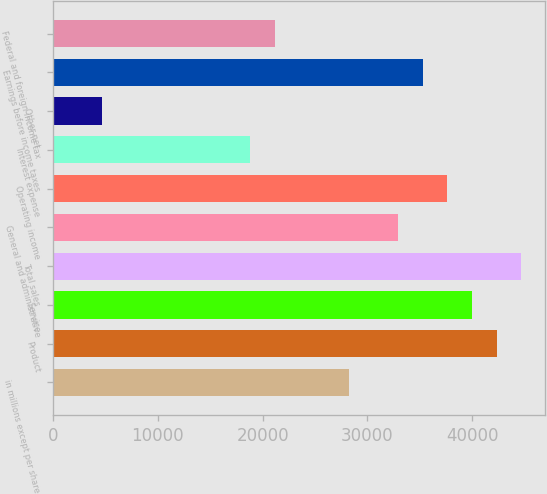<chart> <loc_0><loc_0><loc_500><loc_500><bar_chart><fcel>in millions except per share<fcel>Product<fcel>Service<fcel>Total sales<fcel>General and administrative<fcel>Operating income<fcel>Interest expense<fcel>Other net<fcel>Earnings before income taxes<fcel>Federal and foreign income tax<nl><fcel>28229.1<fcel>42338.5<fcel>39986.9<fcel>44690<fcel>32932.2<fcel>37635.3<fcel>18822.9<fcel>4713.51<fcel>35283.8<fcel>21174.4<nl></chart> 